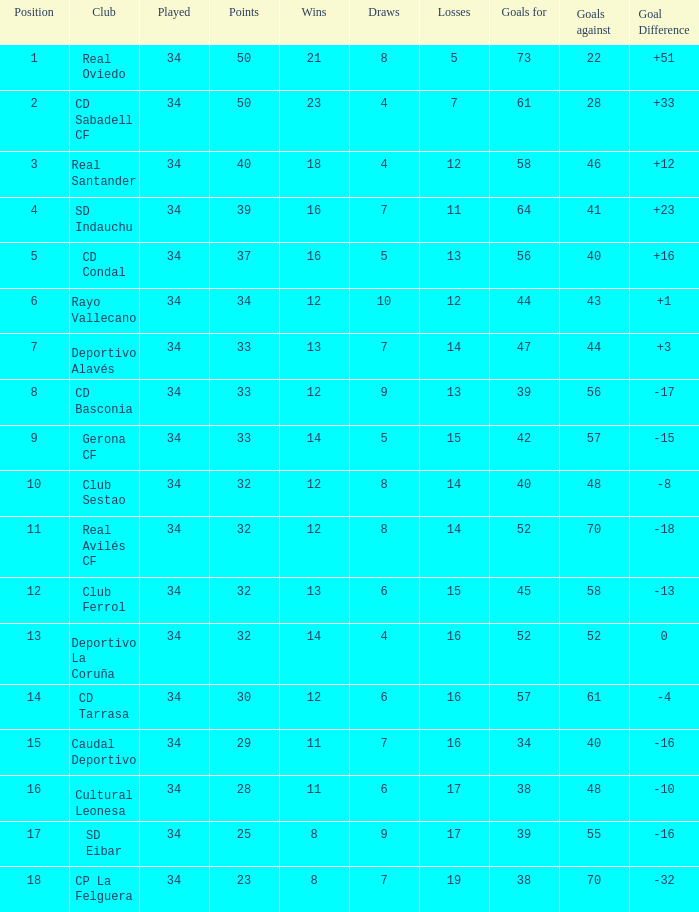Which Wins have a Goal Difference larger than 0, and Goals against larger than 40, and a Position smaller than 6, and a Club of sd indauchu? 16.0. 